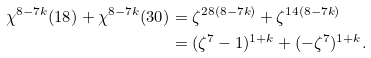Convert formula to latex. <formula><loc_0><loc_0><loc_500><loc_500>\chi ^ { 8 - 7 k } ( 1 8 ) + \chi ^ { 8 - 7 k } ( 3 0 ) & = \zeta ^ { 2 8 ( 8 - 7 k ) } + \zeta ^ { 1 4 ( 8 - 7 k ) } \\ & = ( \zeta ^ { 7 } - 1 ) ^ { 1 + k } + ( - \zeta ^ { 7 } ) ^ { 1 + k } .</formula> 